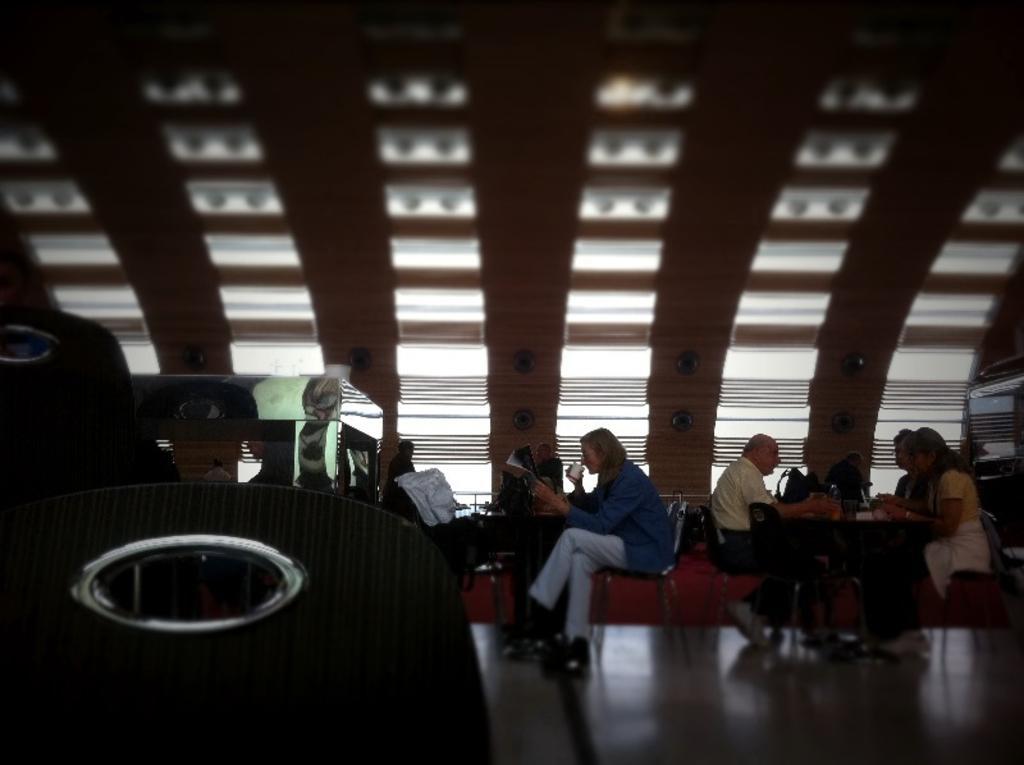Please provide a concise description of this image. In the center of the image we can see tables and persons sitting on the chairs. On the table we can see handbags. In the background there are lights and wall. 